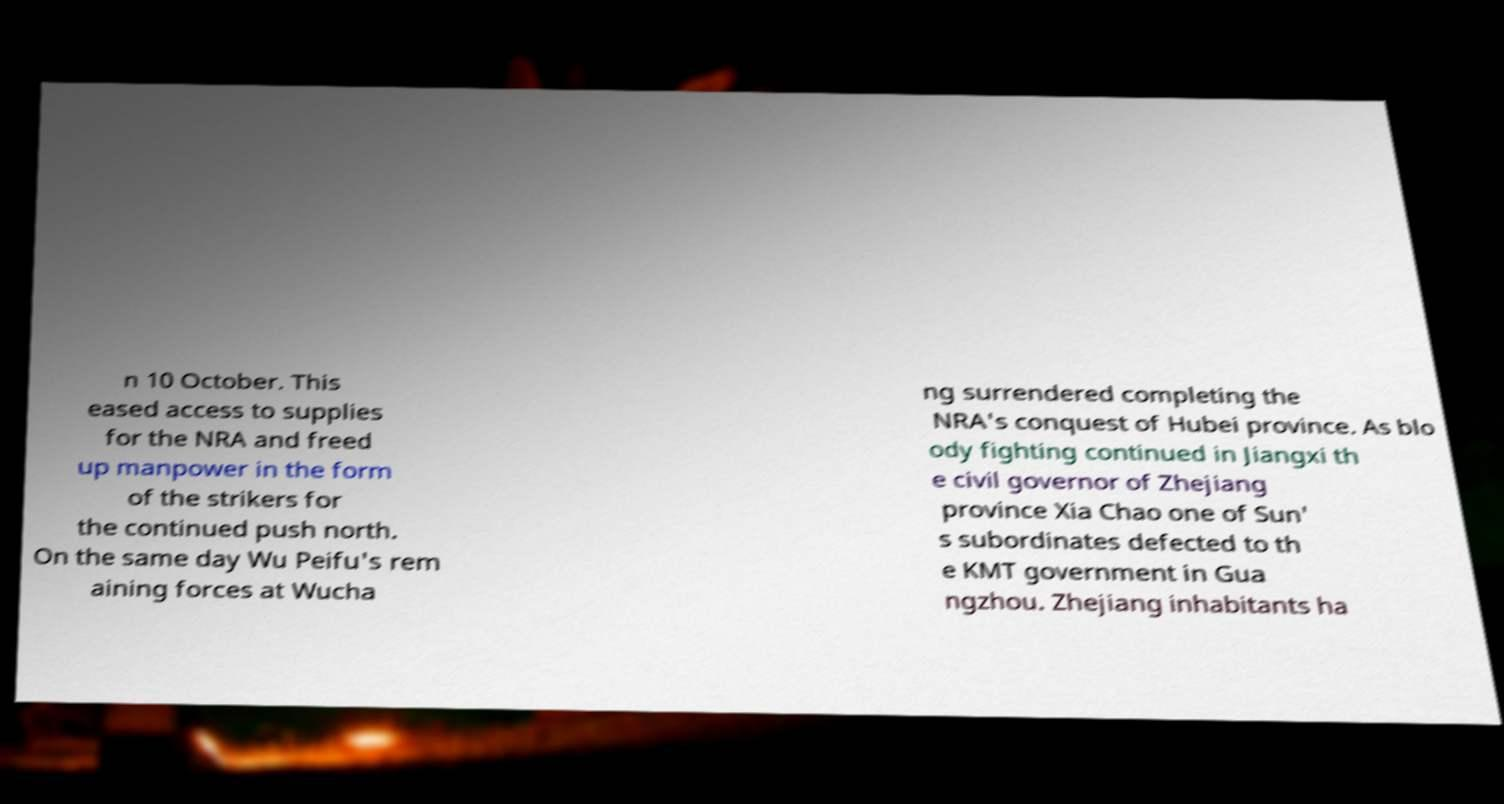Please read and relay the text visible in this image. What does it say? n 10 October. This eased access to supplies for the NRA and freed up manpower in the form of the strikers for the continued push north. On the same day Wu Peifu's rem aining forces at Wucha ng surrendered completing the NRA's conquest of Hubei province. As blo ody fighting continued in Jiangxi th e civil governor of Zhejiang province Xia Chao one of Sun' s subordinates defected to th e KMT government in Gua ngzhou. Zhejiang inhabitants ha 